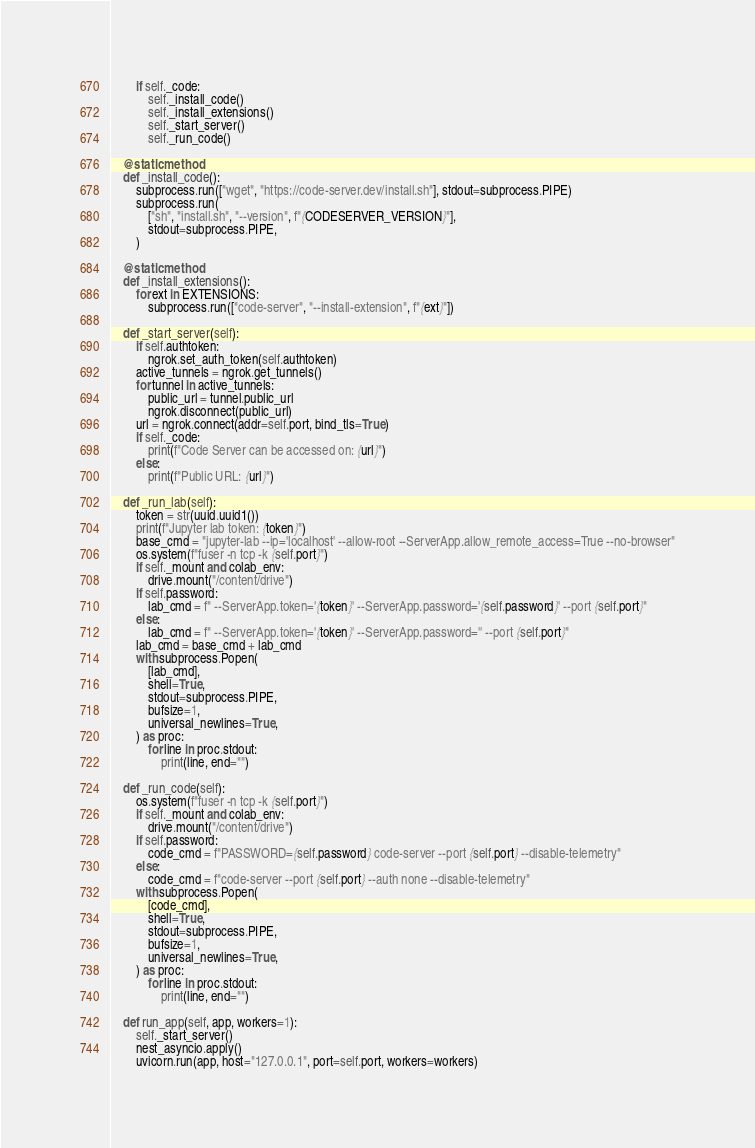Convert code to text. <code><loc_0><loc_0><loc_500><loc_500><_Python_>        if self._code:
            self._install_code()
            self._install_extensions()
            self._start_server()
            self._run_code()

    @staticmethod
    def _install_code():
        subprocess.run(["wget", "https://code-server.dev/install.sh"], stdout=subprocess.PIPE)
        subprocess.run(
            ["sh", "install.sh", "--version", f"{CODESERVER_VERSION}"],
            stdout=subprocess.PIPE,
        )

    @staticmethod
    def _install_extensions():
        for ext in EXTENSIONS:
            subprocess.run(["code-server", "--install-extension", f"{ext}"])

    def _start_server(self):
        if self.authtoken:
            ngrok.set_auth_token(self.authtoken)
        active_tunnels = ngrok.get_tunnels()
        for tunnel in active_tunnels:
            public_url = tunnel.public_url
            ngrok.disconnect(public_url)
        url = ngrok.connect(addr=self.port, bind_tls=True)
        if self._code:
            print(f"Code Server can be accessed on: {url}")
        else:
            print(f"Public URL: {url}")

    def _run_lab(self):
        token = str(uuid.uuid1())
        print(f"Jupyter lab token: {token}")
        base_cmd = "jupyter-lab --ip='localhost' --allow-root --ServerApp.allow_remote_access=True --no-browser"
        os.system(f"fuser -n tcp -k {self.port}")
        if self._mount and colab_env:
            drive.mount("/content/drive")
        if self.password:
            lab_cmd = f" --ServerApp.token='{token}' --ServerApp.password='{self.password}' --port {self.port}"
        else:
            lab_cmd = f" --ServerApp.token='{token}' --ServerApp.password='' --port {self.port}"
        lab_cmd = base_cmd + lab_cmd
        with subprocess.Popen(
            [lab_cmd],
            shell=True,
            stdout=subprocess.PIPE,
            bufsize=1,
            universal_newlines=True,
        ) as proc:
            for line in proc.stdout:
                print(line, end="")

    def _run_code(self):
        os.system(f"fuser -n tcp -k {self.port}")
        if self._mount and colab_env:
            drive.mount("/content/drive")
        if self.password:
            code_cmd = f"PASSWORD={self.password} code-server --port {self.port} --disable-telemetry"
        else:
            code_cmd = f"code-server --port {self.port} --auth none --disable-telemetry"
        with subprocess.Popen(
            [code_cmd],
            shell=True,
            stdout=subprocess.PIPE,
            bufsize=1,
            universal_newlines=True,
        ) as proc:
            for line in proc.stdout:
                print(line, end="")

    def run_app(self, app, workers=1):
        self._start_server()
        nest_asyncio.apply()
        uvicorn.run(app, host="127.0.0.1", port=self.port, workers=workers)
</code> 